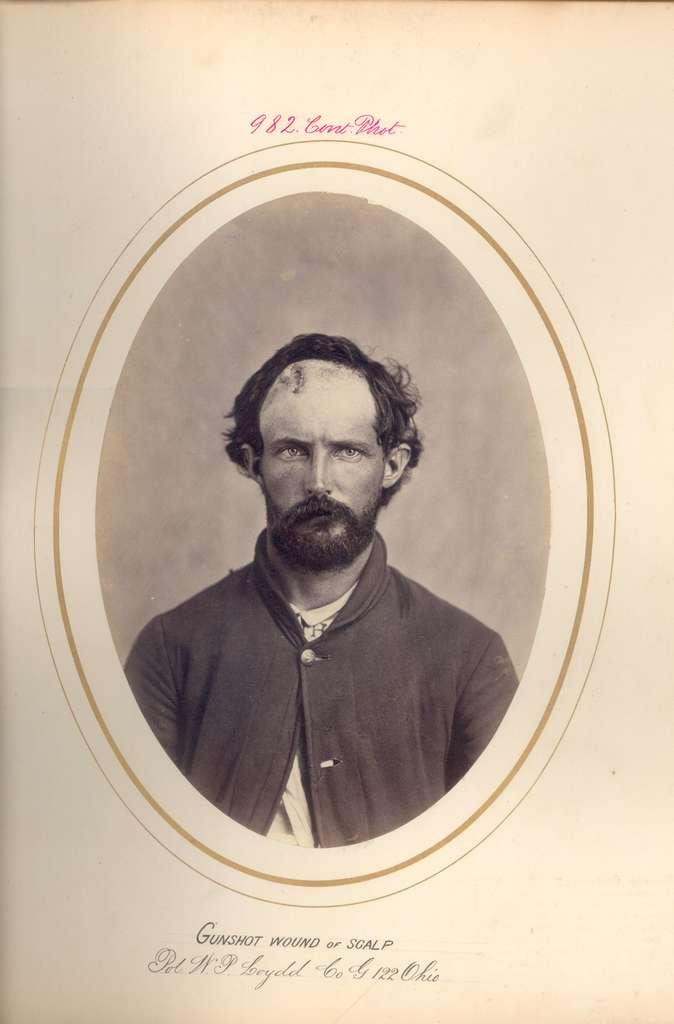What is the main subject of the paper in the image? There is an image of a person on the paper. What else can be seen on the paper besides the image? There is text on the paper. What type of rod can be seen holding up the paper in the image? There is no rod present in the image; the paper is not being held up by any visible object. 